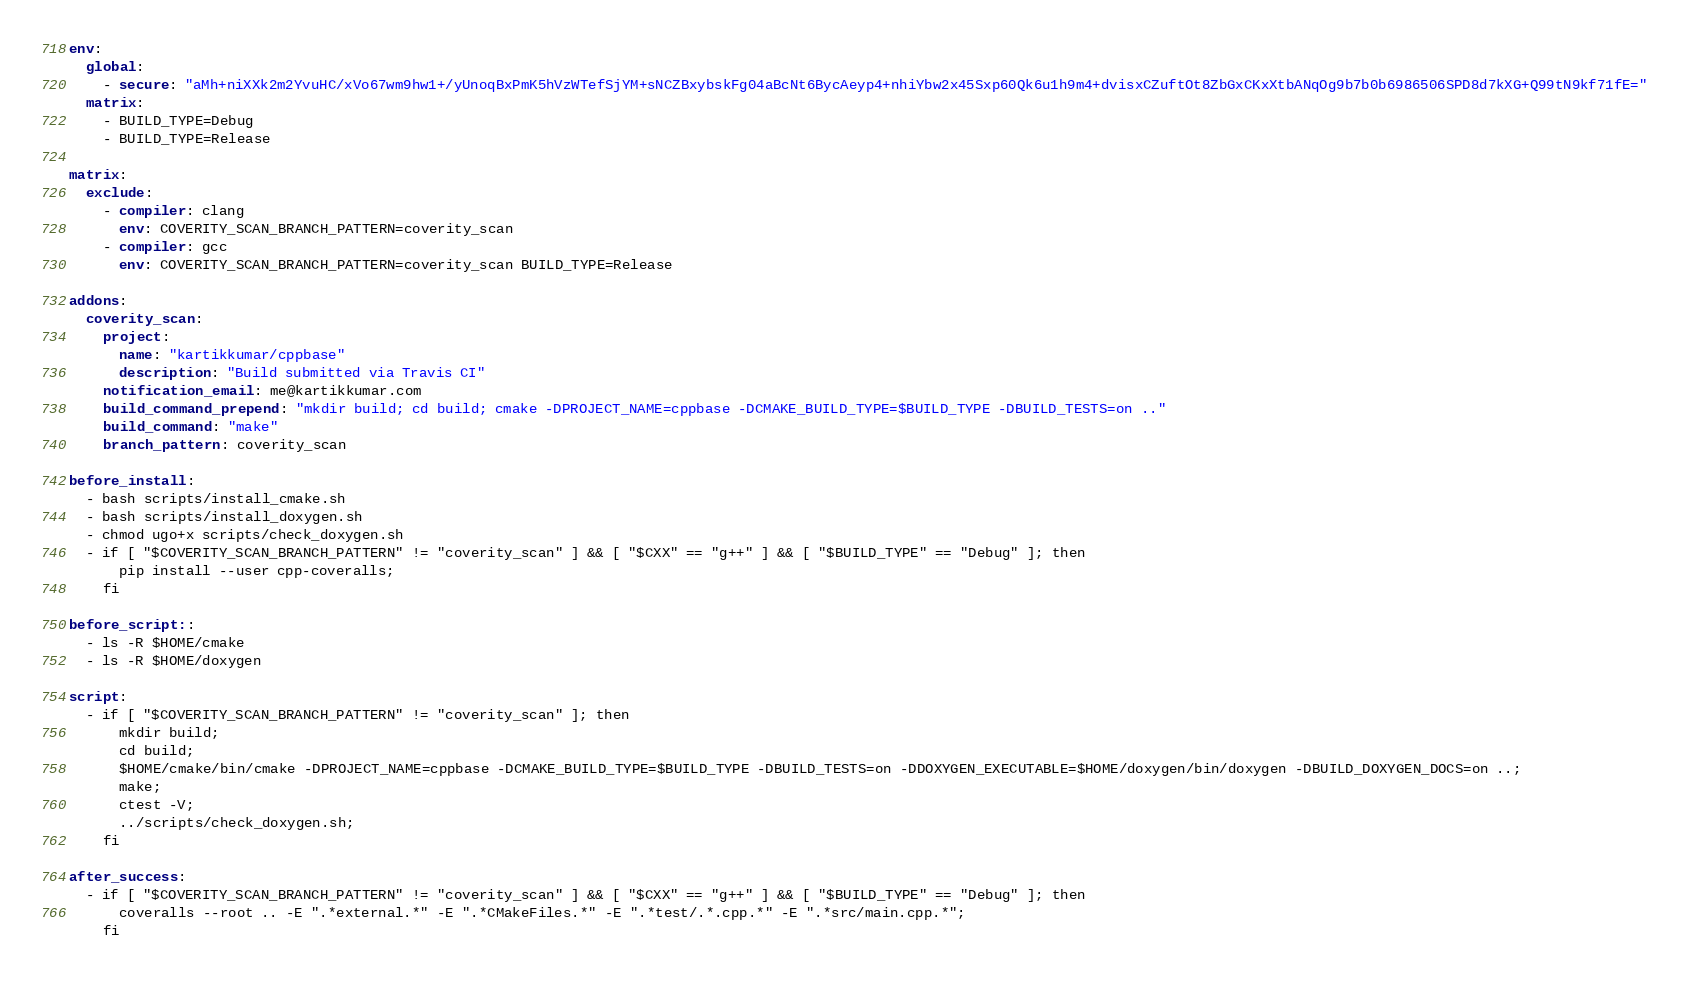Convert code to text. <code><loc_0><loc_0><loc_500><loc_500><_YAML_>env:
  global:
    - secure: "aMh+niXXk2m2YvuHC/xVo67wm9hw1+/yUnoqBxPmK5hVzWTefSjYM+sNCZBxybskFg04aBcNt6BycAeyp4+nhiYbw2x45Sxp60Qk6u1h9m4+dvisxCZuftOt8ZbGxCKxXtbANqOg9b7b0b6986506SPD8d7kXG+Q99tN9kf71fE="
  matrix:
    - BUILD_TYPE=Debug
    - BUILD_TYPE=Release

matrix:
  exclude:
    - compiler: clang
      env: COVERITY_SCAN_BRANCH_PATTERN=coverity_scan
    - compiler: gcc
      env: COVERITY_SCAN_BRANCH_PATTERN=coverity_scan BUILD_TYPE=Release

addons:
  coverity_scan:
    project:
      name: "kartikkumar/cppbase"
      description: "Build submitted via Travis CI"
    notification_email: me@kartikkumar.com
    build_command_prepend: "mkdir build; cd build; cmake -DPROJECT_NAME=cppbase -DCMAKE_BUILD_TYPE=$BUILD_TYPE -DBUILD_TESTS=on .."
    build_command: "make"
    branch_pattern: coverity_scan

before_install:
  - bash scripts/install_cmake.sh
  - bash scripts/install_doxygen.sh
  - chmod ugo+x scripts/check_doxygen.sh
  - if [ "$COVERITY_SCAN_BRANCH_PATTERN" != "coverity_scan" ] && [ "$CXX" == "g++" ] && [ "$BUILD_TYPE" == "Debug" ]; then
      pip install --user cpp-coveralls;
    fi

before_script::
  - ls -R $HOME/cmake
  - ls -R $HOME/doxygen

script:
  - if [ "$COVERITY_SCAN_BRANCH_PATTERN" != "coverity_scan" ]; then
      mkdir build;
      cd build;
      $HOME/cmake/bin/cmake -DPROJECT_NAME=cppbase -DCMAKE_BUILD_TYPE=$BUILD_TYPE -DBUILD_TESTS=on -DDOXYGEN_EXECUTABLE=$HOME/doxygen/bin/doxygen -DBUILD_DOXYGEN_DOCS=on ..;
      make;
      ctest -V;
      ../scripts/check_doxygen.sh;
    fi

after_success:
  - if [ "$COVERITY_SCAN_BRANCH_PATTERN" != "coverity_scan" ] && [ "$CXX" == "g++" ] && [ "$BUILD_TYPE" == "Debug" ]; then
      coveralls --root .. -E ".*external.*" -E ".*CMakeFiles.*" -E ".*test/.*.cpp.*" -E ".*src/main.cpp.*";
    fi
</code> 